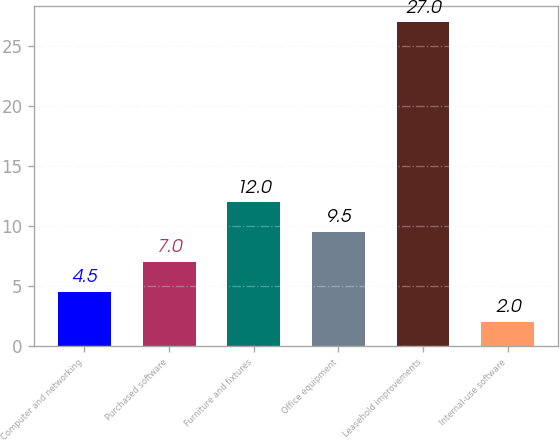<chart> <loc_0><loc_0><loc_500><loc_500><bar_chart><fcel>Computer and networking<fcel>Purchased software<fcel>Furniture and fixtures<fcel>Office equipment<fcel>Leasehold improvements<fcel>Internal-use software<nl><fcel>4.5<fcel>7<fcel>12<fcel>9.5<fcel>27<fcel>2<nl></chart> 